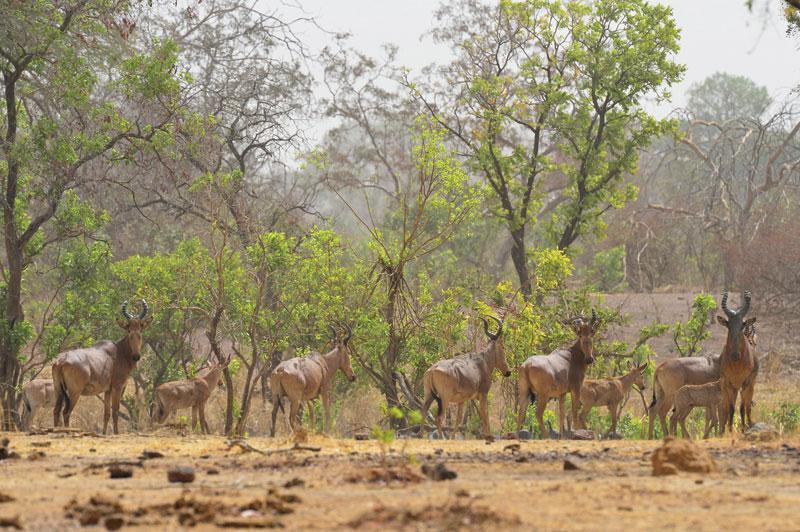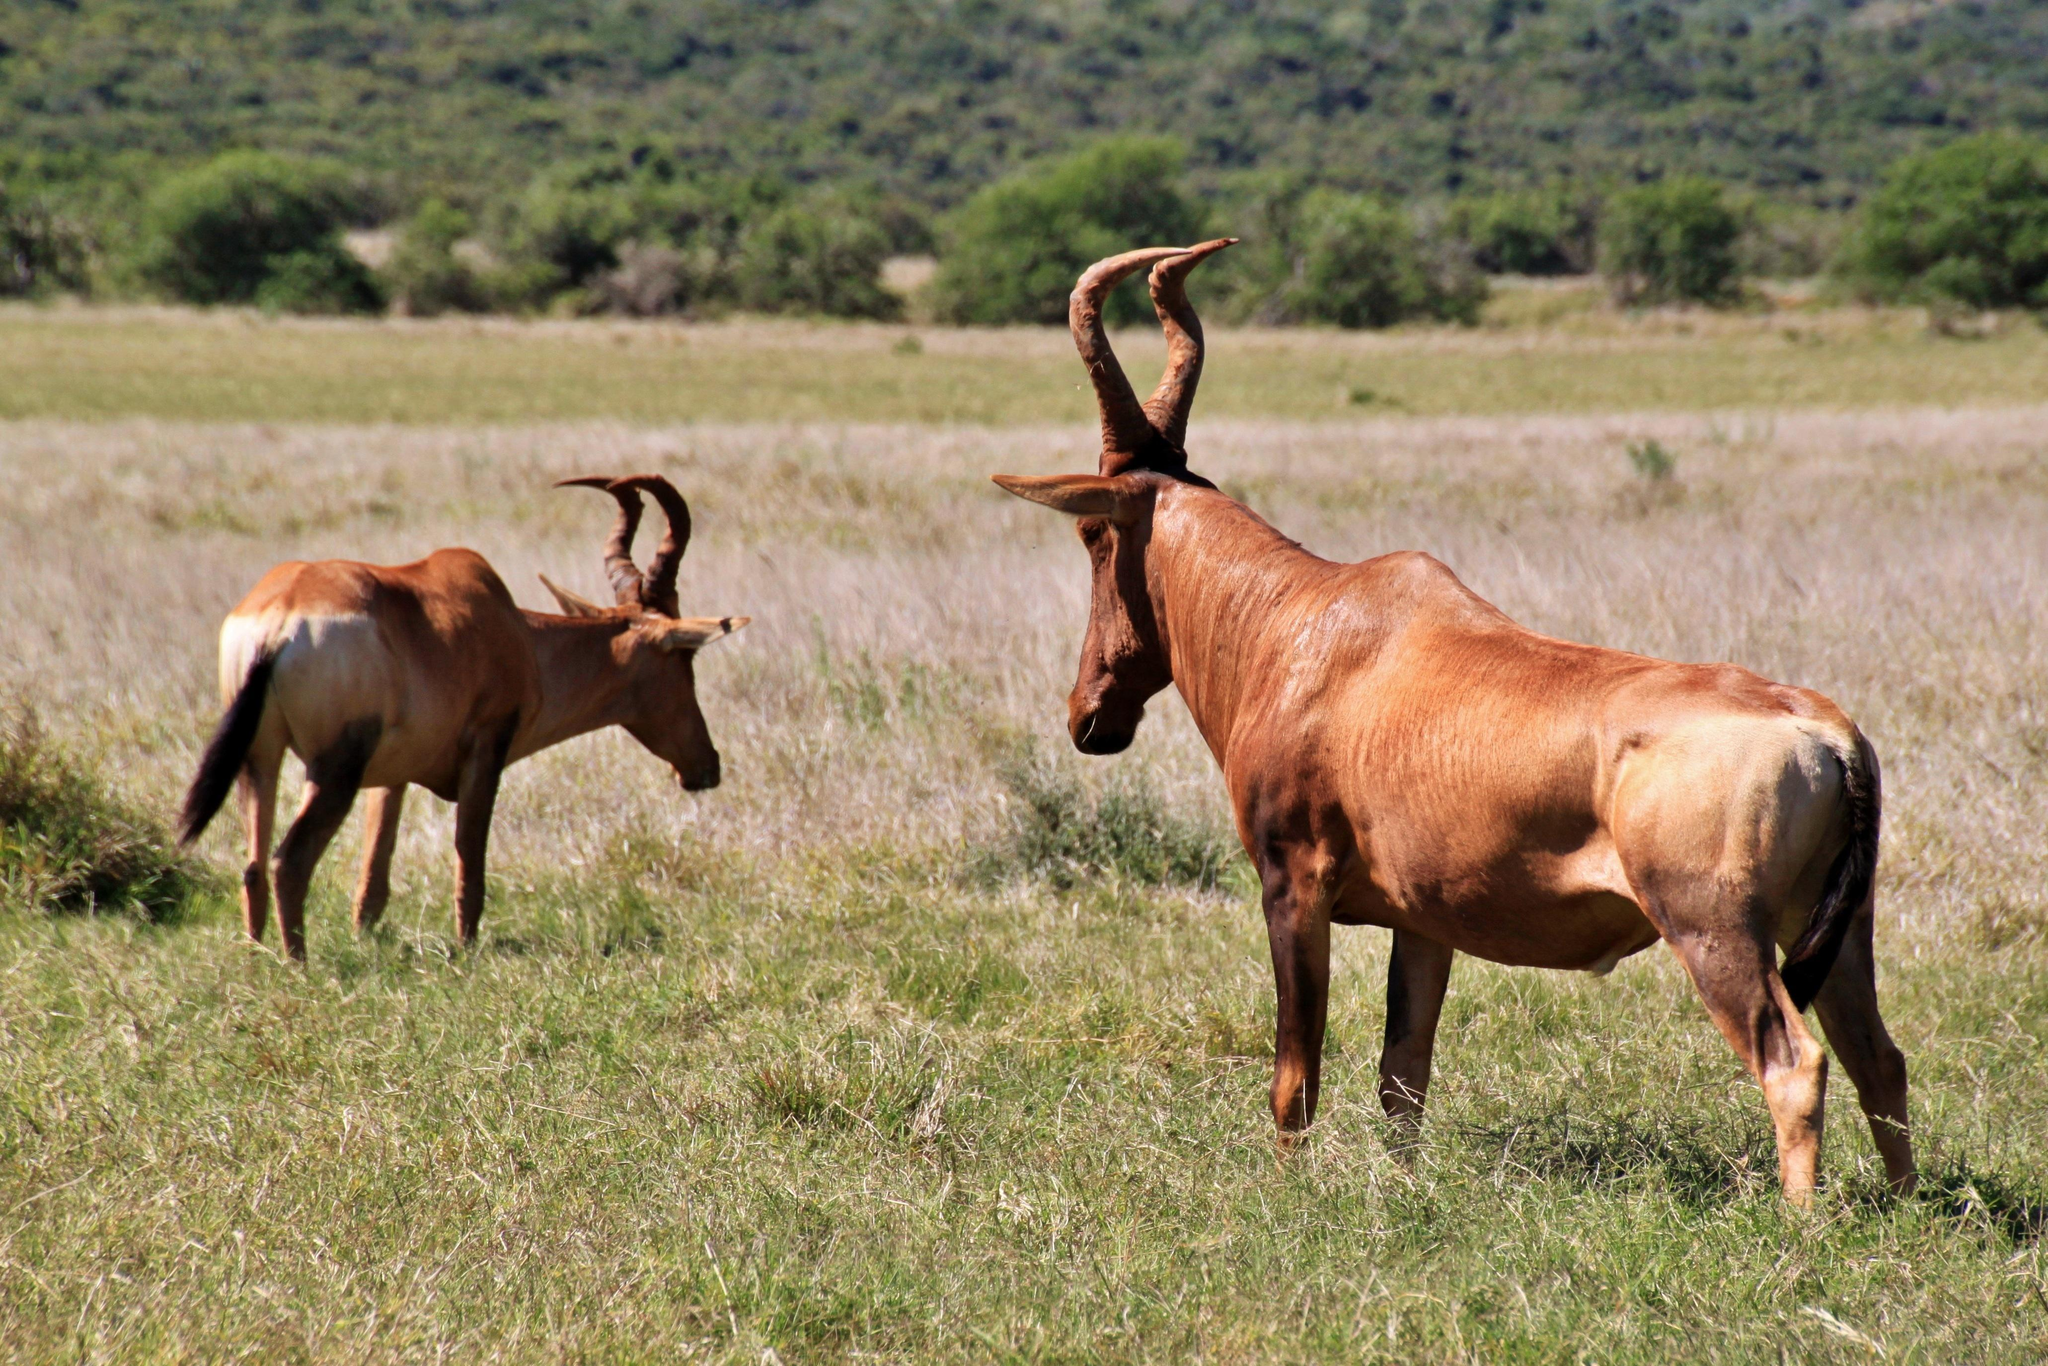The first image is the image on the left, the second image is the image on the right. Evaluate the accuracy of this statement regarding the images: "One of the images has exactly two animals in it.". Is it true? Answer yes or no. Yes. 